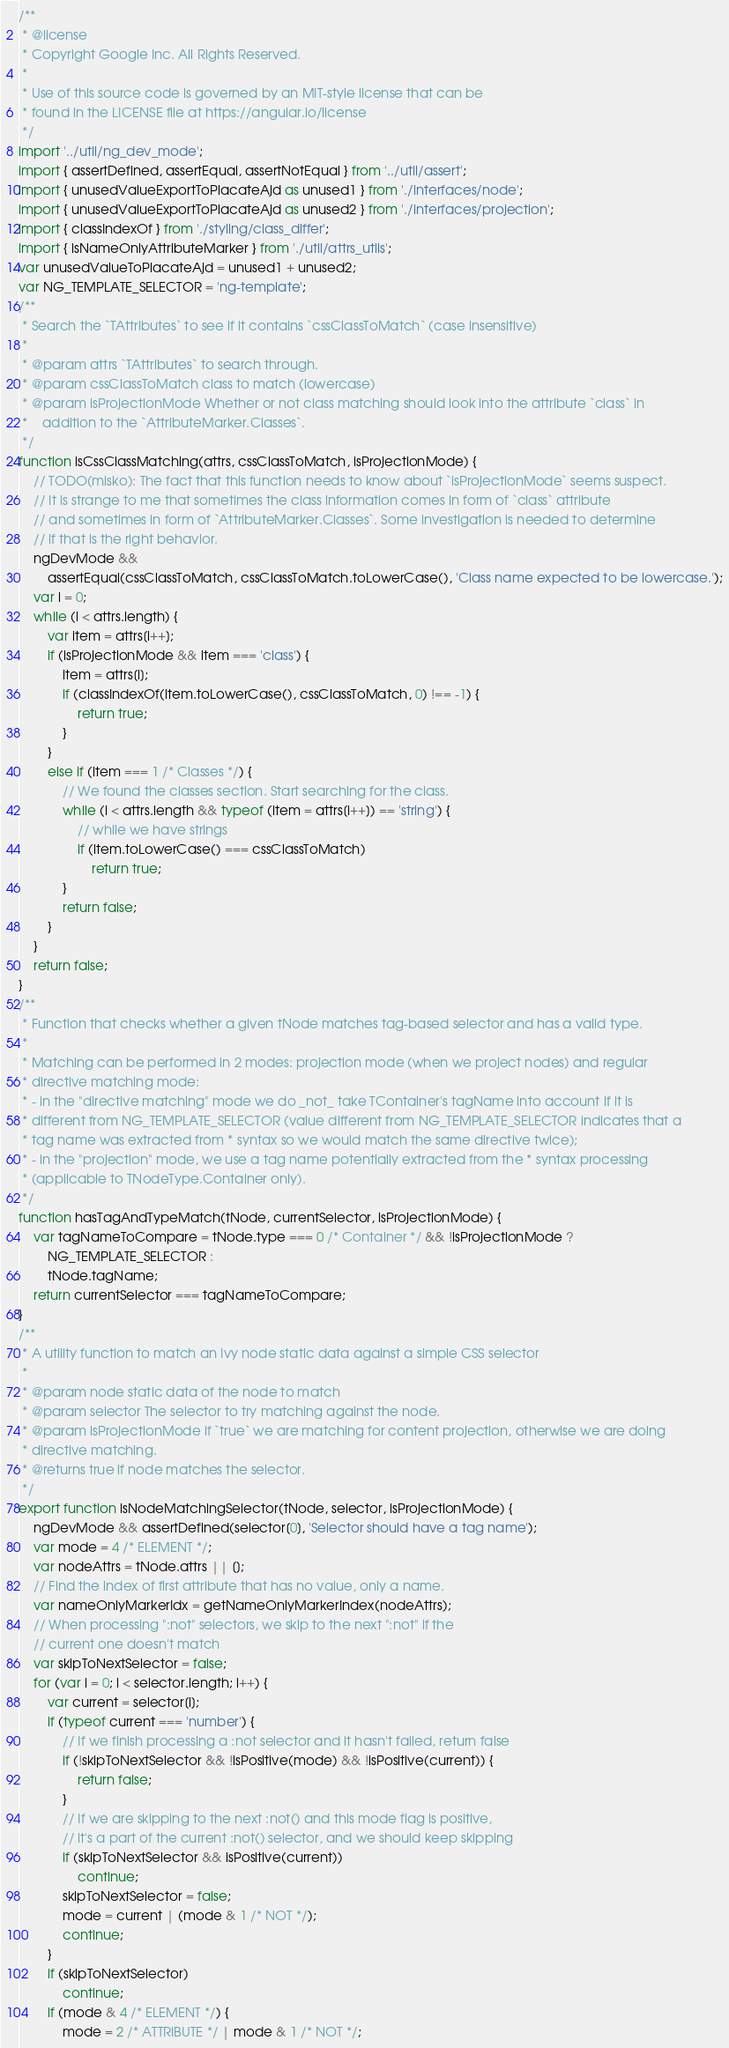<code> <loc_0><loc_0><loc_500><loc_500><_JavaScript_>/**
 * @license
 * Copyright Google Inc. All Rights Reserved.
 *
 * Use of this source code is governed by an MIT-style license that can be
 * found in the LICENSE file at https://angular.io/license
 */
import '../util/ng_dev_mode';
import { assertDefined, assertEqual, assertNotEqual } from '../util/assert';
import { unusedValueExportToPlacateAjd as unused1 } from './interfaces/node';
import { unusedValueExportToPlacateAjd as unused2 } from './interfaces/projection';
import { classIndexOf } from './styling/class_differ';
import { isNameOnlyAttributeMarker } from './util/attrs_utils';
var unusedValueToPlacateAjd = unused1 + unused2;
var NG_TEMPLATE_SELECTOR = 'ng-template';
/**
 * Search the `TAttributes` to see if it contains `cssClassToMatch` (case insensitive)
 *
 * @param attrs `TAttributes` to search through.
 * @param cssClassToMatch class to match (lowercase)
 * @param isProjectionMode Whether or not class matching should look into the attribute `class` in
 *    addition to the `AttributeMarker.Classes`.
 */
function isCssClassMatching(attrs, cssClassToMatch, isProjectionMode) {
    // TODO(misko): The fact that this function needs to know about `isProjectionMode` seems suspect.
    // It is strange to me that sometimes the class information comes in form of `class` attribute
    // and sometimes in form of `AttributeMarker.Classes`. Some investigation is needed to determine
    // if that is the right behavior.
    ngDevMode &&
        assertEqual(cssClassToMatch, cssClassToMatch.toLowerCase(), 'Class name expected to be lowercase.');
    var i = 0;
    while (i < attrs.length) {
        var item = attrs[i++];
        if (isProjectionMode && item === 'class') {
            item = attrs[i];
            if (classIndexOf(item.toLowerCase(), cssClassToMatch, 0) !== -1) {
                return true;
            }
        }
        else if (item === 1 /* Classes */) {
            // We found the classes section. Start searching for the class.
            while (i < attrs.length && typeof (item = attrs[i++]) == 'string') {
                // while we have strings
                if (item.toLowerCase() === cssClassToMatch)
                    return true;
            }
            return false;
        }
    }
    return false;
}
/**
 * Function that checks whether a given tNode matches tag-based selector and has a valid type.
 *
 * Matching can be performed in 2 modes: projection mode (when we project nodes) and regular
 * directive matching mode:
 * - in the "directive matching" mode we do _not_ take TContainer's tagName into account if it is
 * different from NG_TEMPLATE_SELECTOR (value different from NG_TEMPLATE_SELECTOR indicates that a
 * tag name was extracted from * syntax so we would match the same directive twice);
 * - in the "projection" mode, we use a tag name potentially extracted from the * syntax processing
 * (applicable to TNodeType.Container only).
 */
function hasTagAndTypeMatch(tNode, currentSelector, isProjectionMode) {
    var tagNameToCompare = tNode.type === 0 /* Container */ && !isProjectionMode ?
        NG_TEMPLATE_SELECTOR :
        tNode.tagName;
    return currentSelector === tagNameToCompare;
}
/**
 * A utility function to match an Ivy node static data against a simple CSS selector
 *
 * @param node static data of the node to match
 * @param selector The selector to try matching against the node.
 * @param isProjectionMode if `true` we are matching for content projection, otherwise we are doing
 * directive matching.
 * @returns true if node matches the selector.
 */
export function isNodeMatchingSelector(tNode, selector, isProjectionMode) {
    ngDevMode && assertDefined(selector[0], 'Selector should have a tag name');
    var mode = 4 /* ELEMENT */;
    var nodeAttrs = tNode.attrs || [];
    // Find the index of first attribute that has no value, only a name.
    var nameOnlyMarkerIdx = getNameOnlyMarkerIndex(nodeAttrs);
    // When processing ":not" selectors, we skip to the next ":not" if the
    // current one doesn't match
    var skipToNextSelector = false;
    for (var i = 0; i < selector.length; i++) {
        var current = selector[i];
        if (typeof current === 'number') {
            // If we finish processing a :not selector and it hasn't failed, return false
            if (!skipToNextSelector && !isPositive(mode) && !isPositive(current)) {
                return false;
            }
            // If we are skipping to the next :not() and this mode flag is positive,
            // it's a part of the current :not() selector, and we should keep skipping
            if (skipToNextSelector && isPositive(current))
                continue;
            skipToNextSelector = false;
            mode = current | (mode & 1 /* NOT */);
            continue;
        }
        if (skipToNextSelector)
            continue;
        if (mode & 4 /* ELEMENT */) {
            mode = 2 /* ATTRIBUTE */ | mode & 1 /* NOT */;</code> 